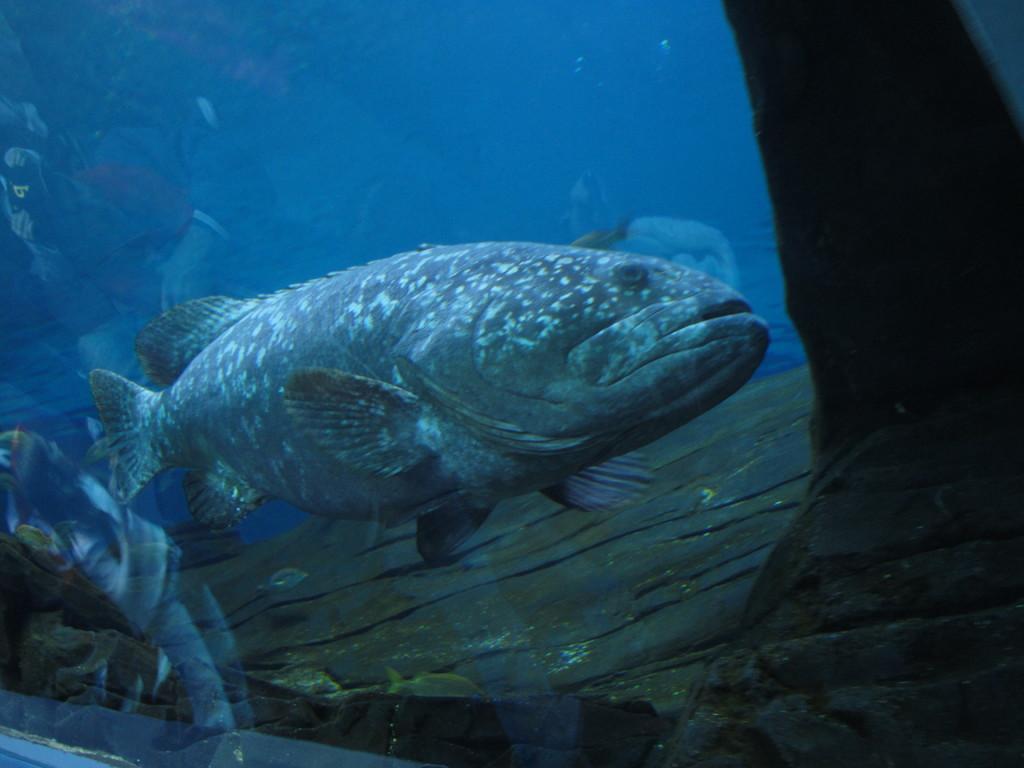In one or two sentences, can you explain what this image depicts? In the middle of the image, there is a fish in the water. Which is covered with a glass. 